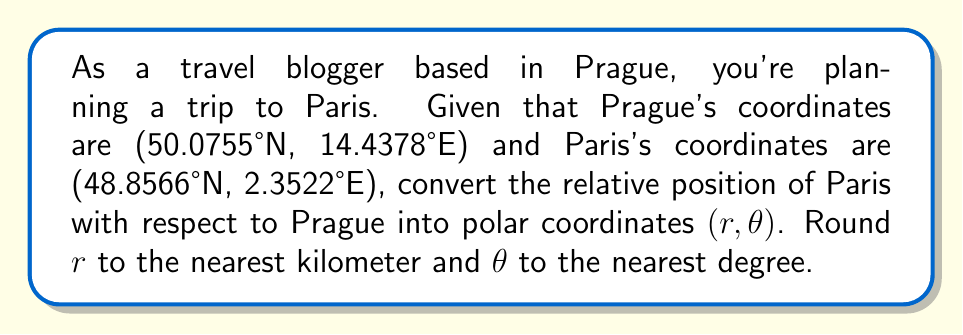What is the answer to this math problem? To solve this problem, we'll follow these steps:

1) First, we need to convert the latitude and longitude differences to Cartesian coordinates. We'll use the approximation that 1° of latitude = 111 km, and 1° of longitude = 111 km * cos(latitude).

2) Calculate the difference in coordinates:
   $\Delta \text{lat} = 48.8566° - 50.0755° = -1.2189°$
   $\Delta \text{long} = 2.3522° - 14.4378° = -12.0856°$

3) Convert to kilometers:
   $y = -1.2189° * 111 \text{ km/°} = -135.3 \text{ km}$
   $x = -12.0856° * 111 \text{ km/°} * \cos(49.466°) = -881.7 \text{ km}$
   (We use the average latitude (49.466°) for the longitude conversion)

4) Now we have the Cartesian coordinates (-881.7 km, -135.3 km). Let's convert to polar form $(r, \theta)$:

   $r = \sqrt{x^2 + y^2} = \sqrt{(-881.7)^2 + (-135.3)^2} = 892.1 \text{ km}$

   $\theta = \arctan(\frac{y}{x}) = \arctan(\frac{-135.3}{-881.7}) = 8.71°$

5) However, since both x and y are negative, we need to add 180° to this angle:
   $\theta = 8.71° + 180° = 188.71°$

6) Rounding to the nearest km and degree:
   $r \approx 892 \text{ km}$
   $\theta \approx 189°$
Answer: $(892 \text{ km}, 189°)$ 